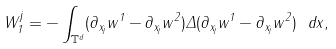Convert formula to latex. <formula><loc_0><loc_0><loc_500><loc_500>W ^ { j } _ { 1 } = - \int _ { \mathbb { T } ^ { d } } ( \partial _ { x _ { j } } w ^ { 1 } - \partial _ { x _ { j } } w ^ { 2 } ) \Delta ( \partial _ { x _ { j } } w ^ { 1 } - \partial _ { x _ { j } } w ^ { 2 } ) \ d x ,</formula> 